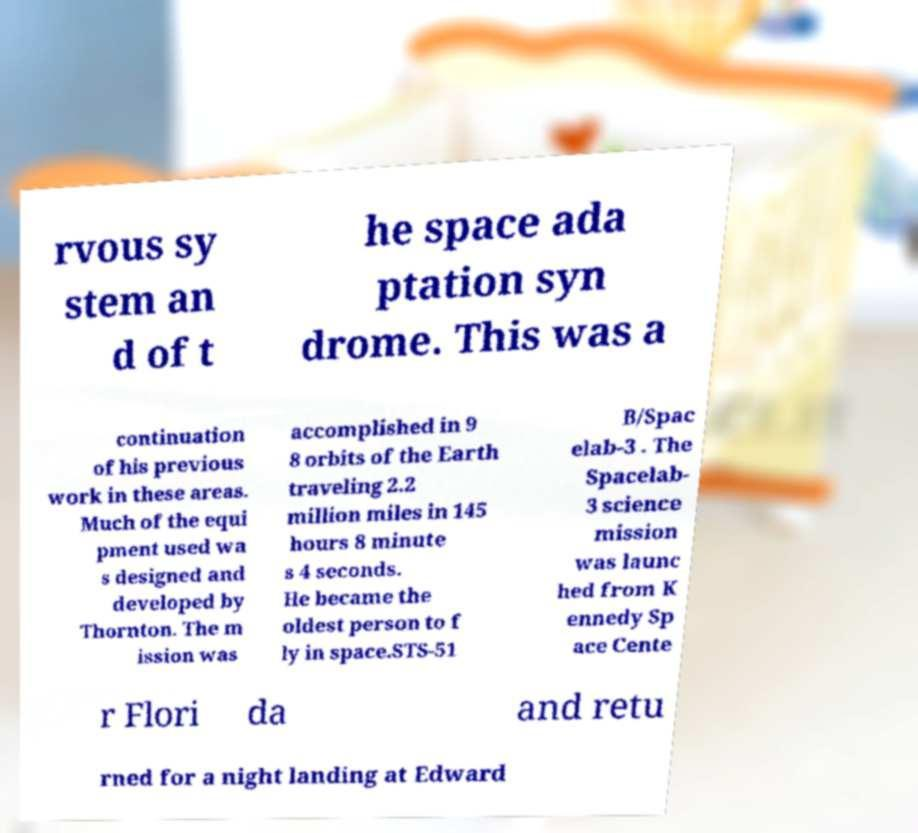Can you accurately transcribe the text from the provided image for me? rvous sy stem an d of t he space ada ptation syn drome. This was a continuation of his previous work in these areas. Much of the equi pment used wa s designed and developed by Thornton. The m ission was accomplished in 9 8 orbits of the Earth traveling 2.2 million miles in 145 hours 8 minute s 4 seconds. He became the oldest person to f ly in space.STS-51 B/Spac elab-3 . The Spacelab- 3 science mission was launc hed from K ennedy Sp ace Cente r Flori da and retu rned for a night landing at Edward 